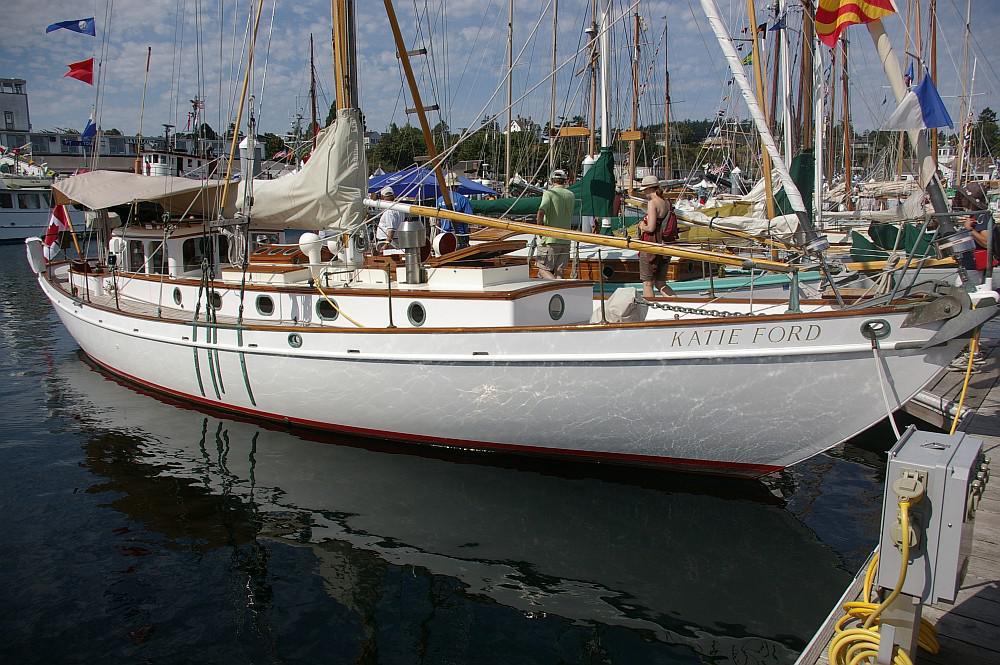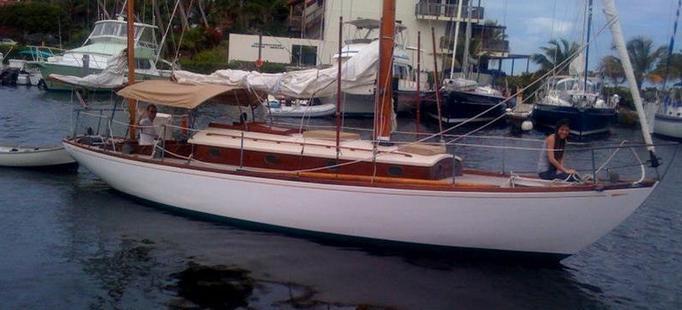The first image is the image on the left, the second image is the image on the right. Analyze the images presented: Is the assertion "Some of the boats have multiple flags attached to them and none are American Flags." valid? Answer yes or no. Yes. 